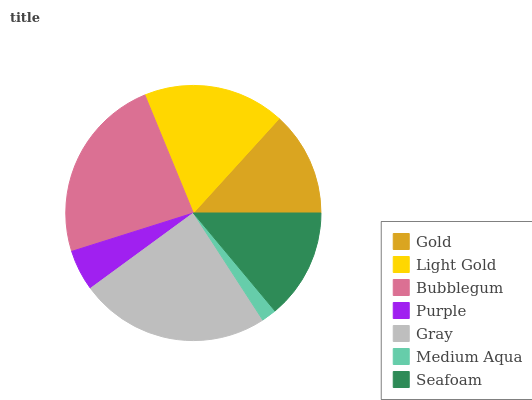Is Medium Aqua the minimum?
Answer yes or no. Yes. Is Gray the maximum?
Answer yes or no. Yes. Is Light Gold the minimum?
Answer yes or no. No. Is Light Gold the maximum?
Answer yes or no. No. Is Light Gold greater than Gold?
Answer yes or no. Yes. Is Gold less than Light Gold?
Answer yes or no. Yes. Is Gold greater than Light Gold?
Answer yes or no. No. Is Light Gold less than Gold?
Answer yes or no. No. Is Seafoam the high median?
Answer yes or no. Yes. Is Seafoam the low median?
Answer yes or no. Yes. Is Gray the high median?
Answer yes or no. No. Is Bubblegum the low median?
Answer yes or no. No. 